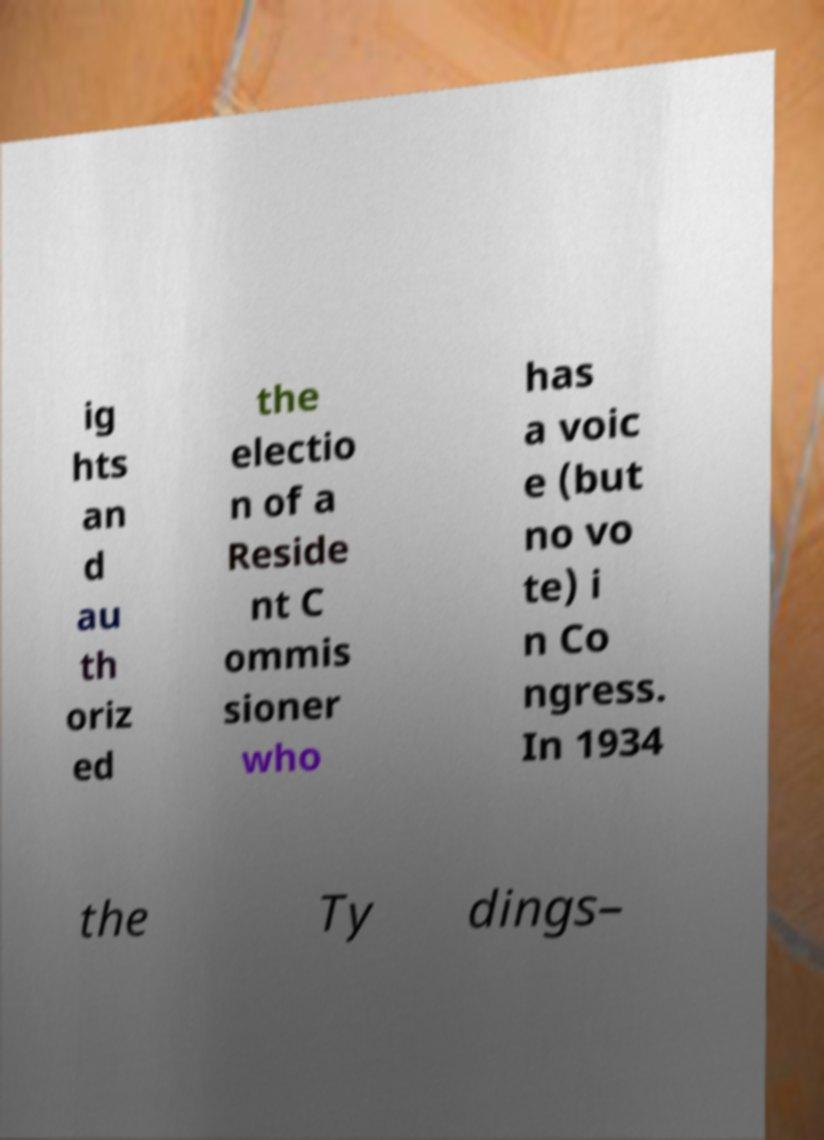For documentation purposes, I need the text within this image transcribed. Could you provide that? ig hts an d au th oriz ed the electio n of a Reside nt C ommis sioner who has a voic e (but no vo te) i n Co ngress. In 1934 the Ty dings– 